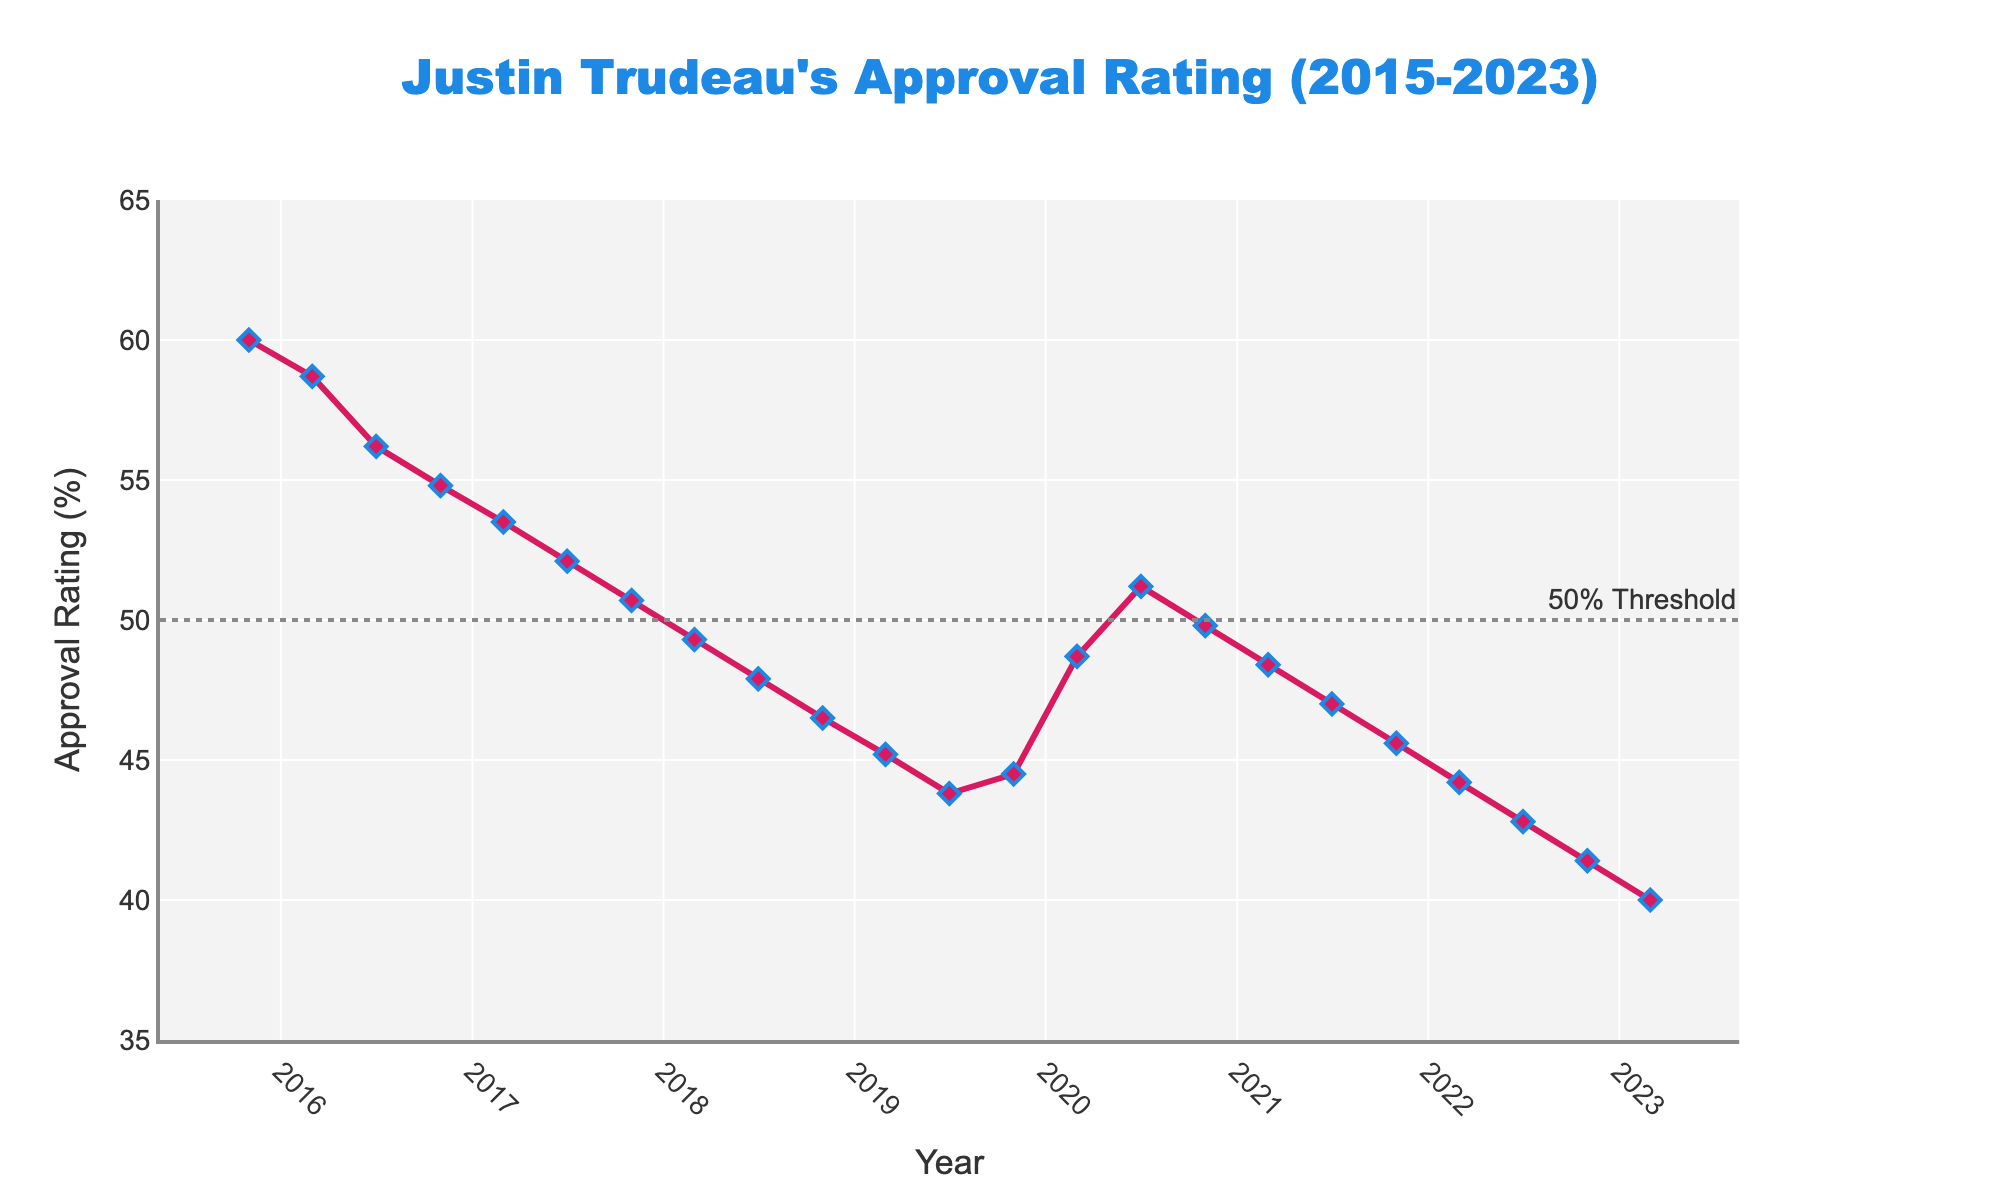What was Justin Trudeau's approval rating when he first became Prime Minister in November 2015? The line chart shows the data starting at November 2015 with an approval rating. Look at the value indicated for this date.
Answer: 60.0% What is the overall trend in Justin Trudeau's approval rating from 2015 to 2023? Observe the direction of the line from 2015 to 2023, noting if it generally goes up or down.
Answer: General decline How did the approval rating change between March 2020 and July 2020? Look at the values at March 2020 and July 2020, and calculate the difference. March 2020 is 48.7%, and July 2020 is 51.2%. Therefore, it increased by 51.2% - 48.7%.
Answer: +2.5% Which year saw the highest approval rating, and what was the rating? Identify the peak point in the graph and note the date and the corresponding value.
Answer: 2015, 60.0% What was the approval rating in March 2023, and how does it compare to the rating in November 2015? Find the values for March 2023 and November 2015 and compare them.
Answer: 40.0%, 20% lower Did Justin Trudeau's approval rating ever drop below 50%? If so, when was the first time this happened? Identify if the line crosses below the 50% reference line and note the first occurrence.
Answer: Yes, November 2017 On average, how did the approval rating change every six months between November 2017 and November 2018? Find the approval ratings for November 2017, March 2018, July 2018, and November 2018, then calculate the average change.
Answer: Declined by ~1.4% every six months What are the lowest three approval ratings recorded in the chart, and when did they occur? Identify the three lowest points on the chart and note the dates and values.
Answer: 40.0% in March 2023, 41.4% in November 2022, 42.8% in July 2022 Between which two consecutive points is the greatest single increase in approval rating observed? Examine the differences between consecutive points and identify the largest increase. This occurs between March 2020 at 48.7% and July 2020 at 51.2%.
Answer: Between March 2020 and July 2020 